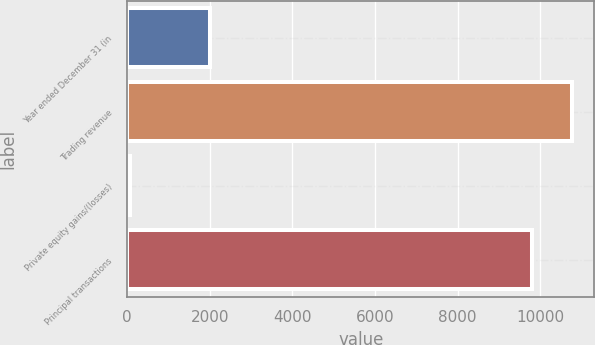Convert chart to OTSL. <chart><loc_0><loc_0><loc_500><loc_500><bar_chart><fcel>Year ended December 31 (in<fcel>Trading revenue<fcel>Private equity gains/(losses)<fcel>Principal transactions<nl><fcel>2009<fcel>10775.6<fcel>74<fcel>9796<nl></chart> 